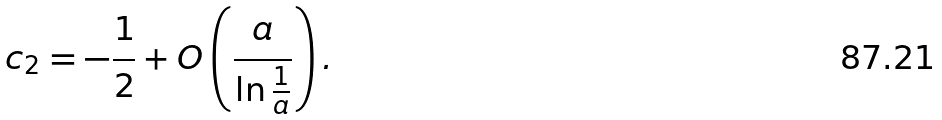<formula> <loc_0><loc_0><loc_500><loc_500>c _ { 2 } = - \frac { 1 } { 2 } + O \left ( \frac { a } { \ln { \frac { 1 } { a } } } \right ) .</formula> 